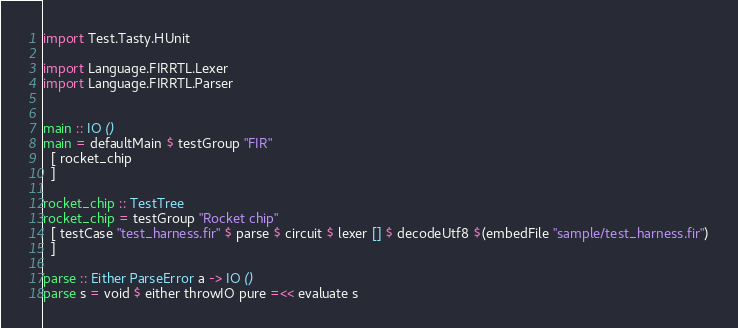Convert code to text. <code><loc_0><loc_0><loc_500><loc_500><_Haskell_>import Test.Tasty.HUnit

import Language.FIRRTL.Lexer
import Language.FIRRTL.Parser


main :: IO ()
main = defaultMain $ testGroup "FIR"
  [ rocket_chip
  ]

rocket_chip :: TestTree
rocket_chip = testGroup "Rocket chip"
  [ testCase "test_harness.fir" $ parse $ circuit $ lexer [] $ decodeUtf8 $(embedFile "sample/test_harness.fir")
  ]

parse :: Either ParseError a -> IO ()
parse s = void $ either throwIO pure =<< evaluate s
</code> 